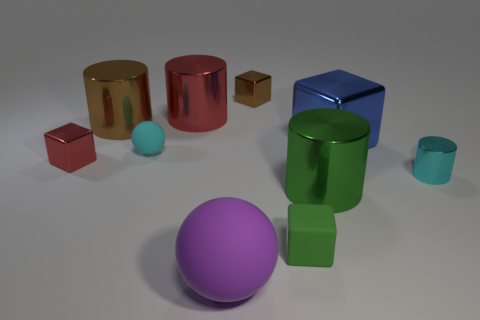Do the small cylinder and the small matte ball have the same color?
Your answer should be compact. Yes. Is there any other thing that has the same color as the large sphere?
Your answer should be compact. No. What shape is the thing that is the same color as the tiny metal cylinder?
Your response must be concise. Sphere. There is a cyan object right of the large green metallic cylinder; how big is it?
Keep it short and to the point. Small. The red object that is the same size as the blue block is what shape?
Make the answer very short. Cylinder. Are the cube on the left side of the big matte thing and the sphere in front of the small red metal thing made of the same material?
Offer a terse response. No. The ball in front of the tiny cyan object that is to the left of the cyan shiny cylinder is made of what material?
Ensure brevity in your answer.  Rubber. What is the size of the rubber object that is behind the red thing in front of the matte ball that is behind the small green matte thing?
Your answer should be very brief. Small. Is the matte block the same size as the cyan sphere?
Your response must be concise. Yes. Do the cyan thing that is to the left of the green block and the matte object in front of the tiny rubber block have the same shape?
Your answer should be very brief. Yes. 